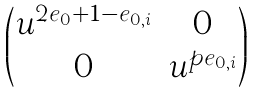Convert formula to latex. <formula><loc_0><loc_0><loc_500><loc_500>\begin{pmatrix} u ^ { 2 e _ { 0 } + 1 - e _ { 0 , i } } & 0 \\ 0 & u ^ { p e _ { 0 , i } } \end{pmatrix}</formula> 